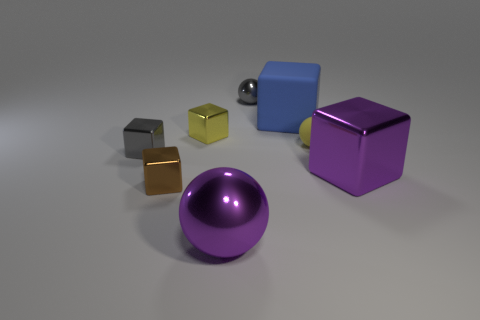Subtract all tiny gray balls. How many balls are left? 2 Add 1 large red shiny cubes. How many objects exist? 9 Subtract 1 spheres. How many spheres are left? 2 Subtract all yellow balls. How many balls are left? 2 Subtract all cubes. How many objects are left? 3 Subtract all rubber things. Subtract all tiny gray shiny balls. How many objects are left? 5 Add 6 large metal things. How many large metal things are left? 8 Add 8 small gray matte balls. How many small gray matte balls exist? 8 Subtract 1 yellow blocks. How many objects are left? 7 Subtract all gray blocks. Subtract all gray balls. How many blocks are left? 4 